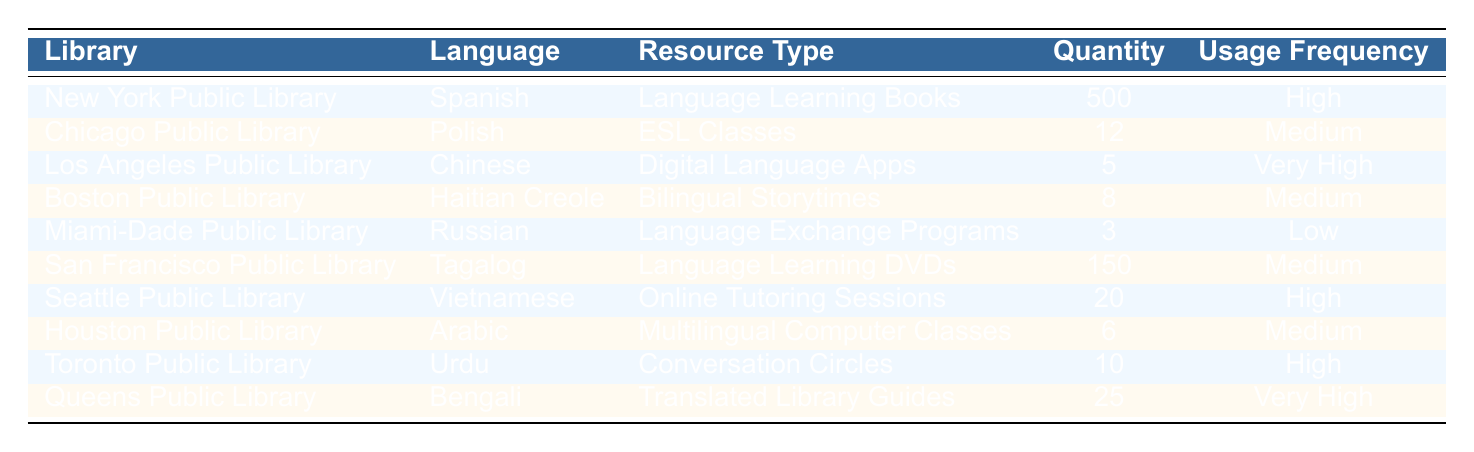What language resources are available at the New York Public Library? The table indicates that the New York Public Library has "Language Learning Books" in Spanish, with a quantity of 500.
Answer: Language Learning Books in Spanish How many ESL classes does the Chicago Public Library offer? The Chicago Public Library offers 12 ESL classes, as stated in the table.
Answer: 12 Which library provides the highest quantity of resources for non-English speakers? By comparing the quantities listed, the New York Public Library stands out with 500 Language Learning Books in Spanish, which is the highest quantity.
Answer: New York Public Library Is there a library that offers multilingual computer classes? Yes, the Houston Public Library provides Multilingual Computer Classes in Arabic, as per the information in the table.
Answer: Yes How many resources does the Miami-Dade Public Library have compared to the Seattle Public Library? The Miami-Dade Public Library has 3 Language Exchange Programs, while the Seattle Public Library has 20 Online Tutoring Sessions. The latter has significantly more resources available.
Answer: Seattle Public Library has more resources What is the total number of language resources across all libraries for low usage frequency? Only the Miami-Dade Public Library has resources categorized as "Low" with 3 Language Exchange Programs. Therefore, the total is 3.
Answer: 3 Are there any libraries that offer resources in languages other than Spanish or Polish? Yes, the table shows various libraries offering resources in languages such as Chinese, Haitian Creole, Russian, Tagalog, Vietnamese, Arabic, Urdu, and Bengali, indicating a diverse range of languages supported.
Answer: Yes Which library has the least quantity of resources according to the table? The Miami-Dade Public Library has the least quantity with only 3 Language Exchange Programs.
Answer: Miami-Dade Public Library What is the average quantity of resources for libraries that offer "High" usage frequency? The libraries with "High" usage frequency are the New York Public Library (500), Seattle Public Library (20), and Toronto Public Library (10). The total is 500 + 20 + 10 = 530. There are 3 libraries, so the average is 530 / 3 = 176.67.
Answer: 176.67 